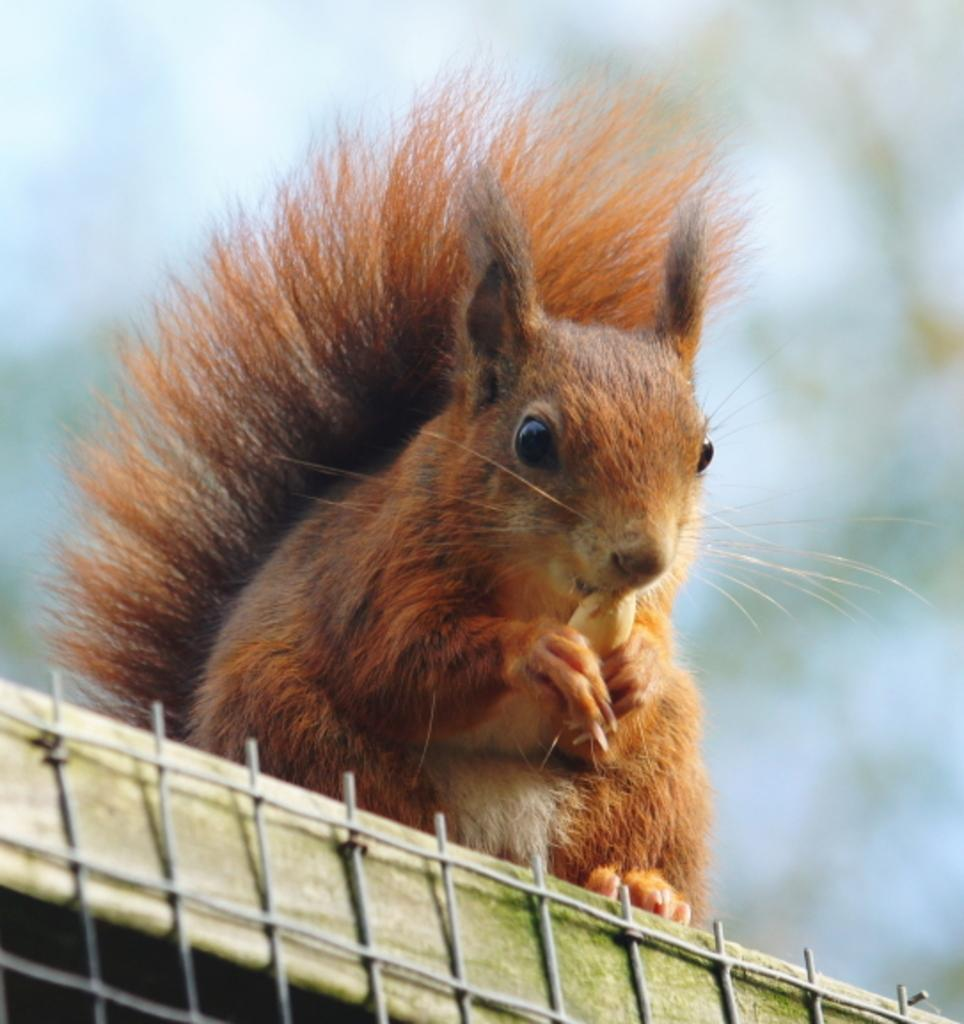What type of creature is in the image? There is an animal in the image. Can you describe the color pattern of the animal? The animal has brown and black colors. What can be observed about the background of the image? The background of the image is blurred. What type of prose is being read by the animal in the image? There is no indication in the image that the animal is reading any prose, as animals do not have the ability to read. 